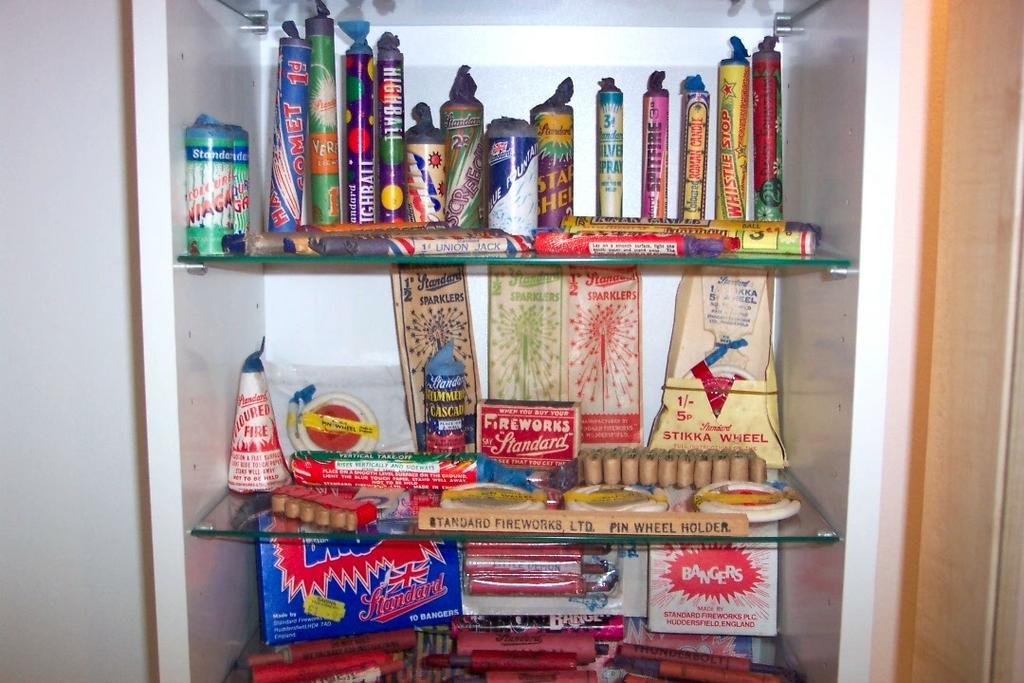Please provide a concise description of this image. In this image we can see different kinds of fireworks arranged in the different shelves of the cupboard. 